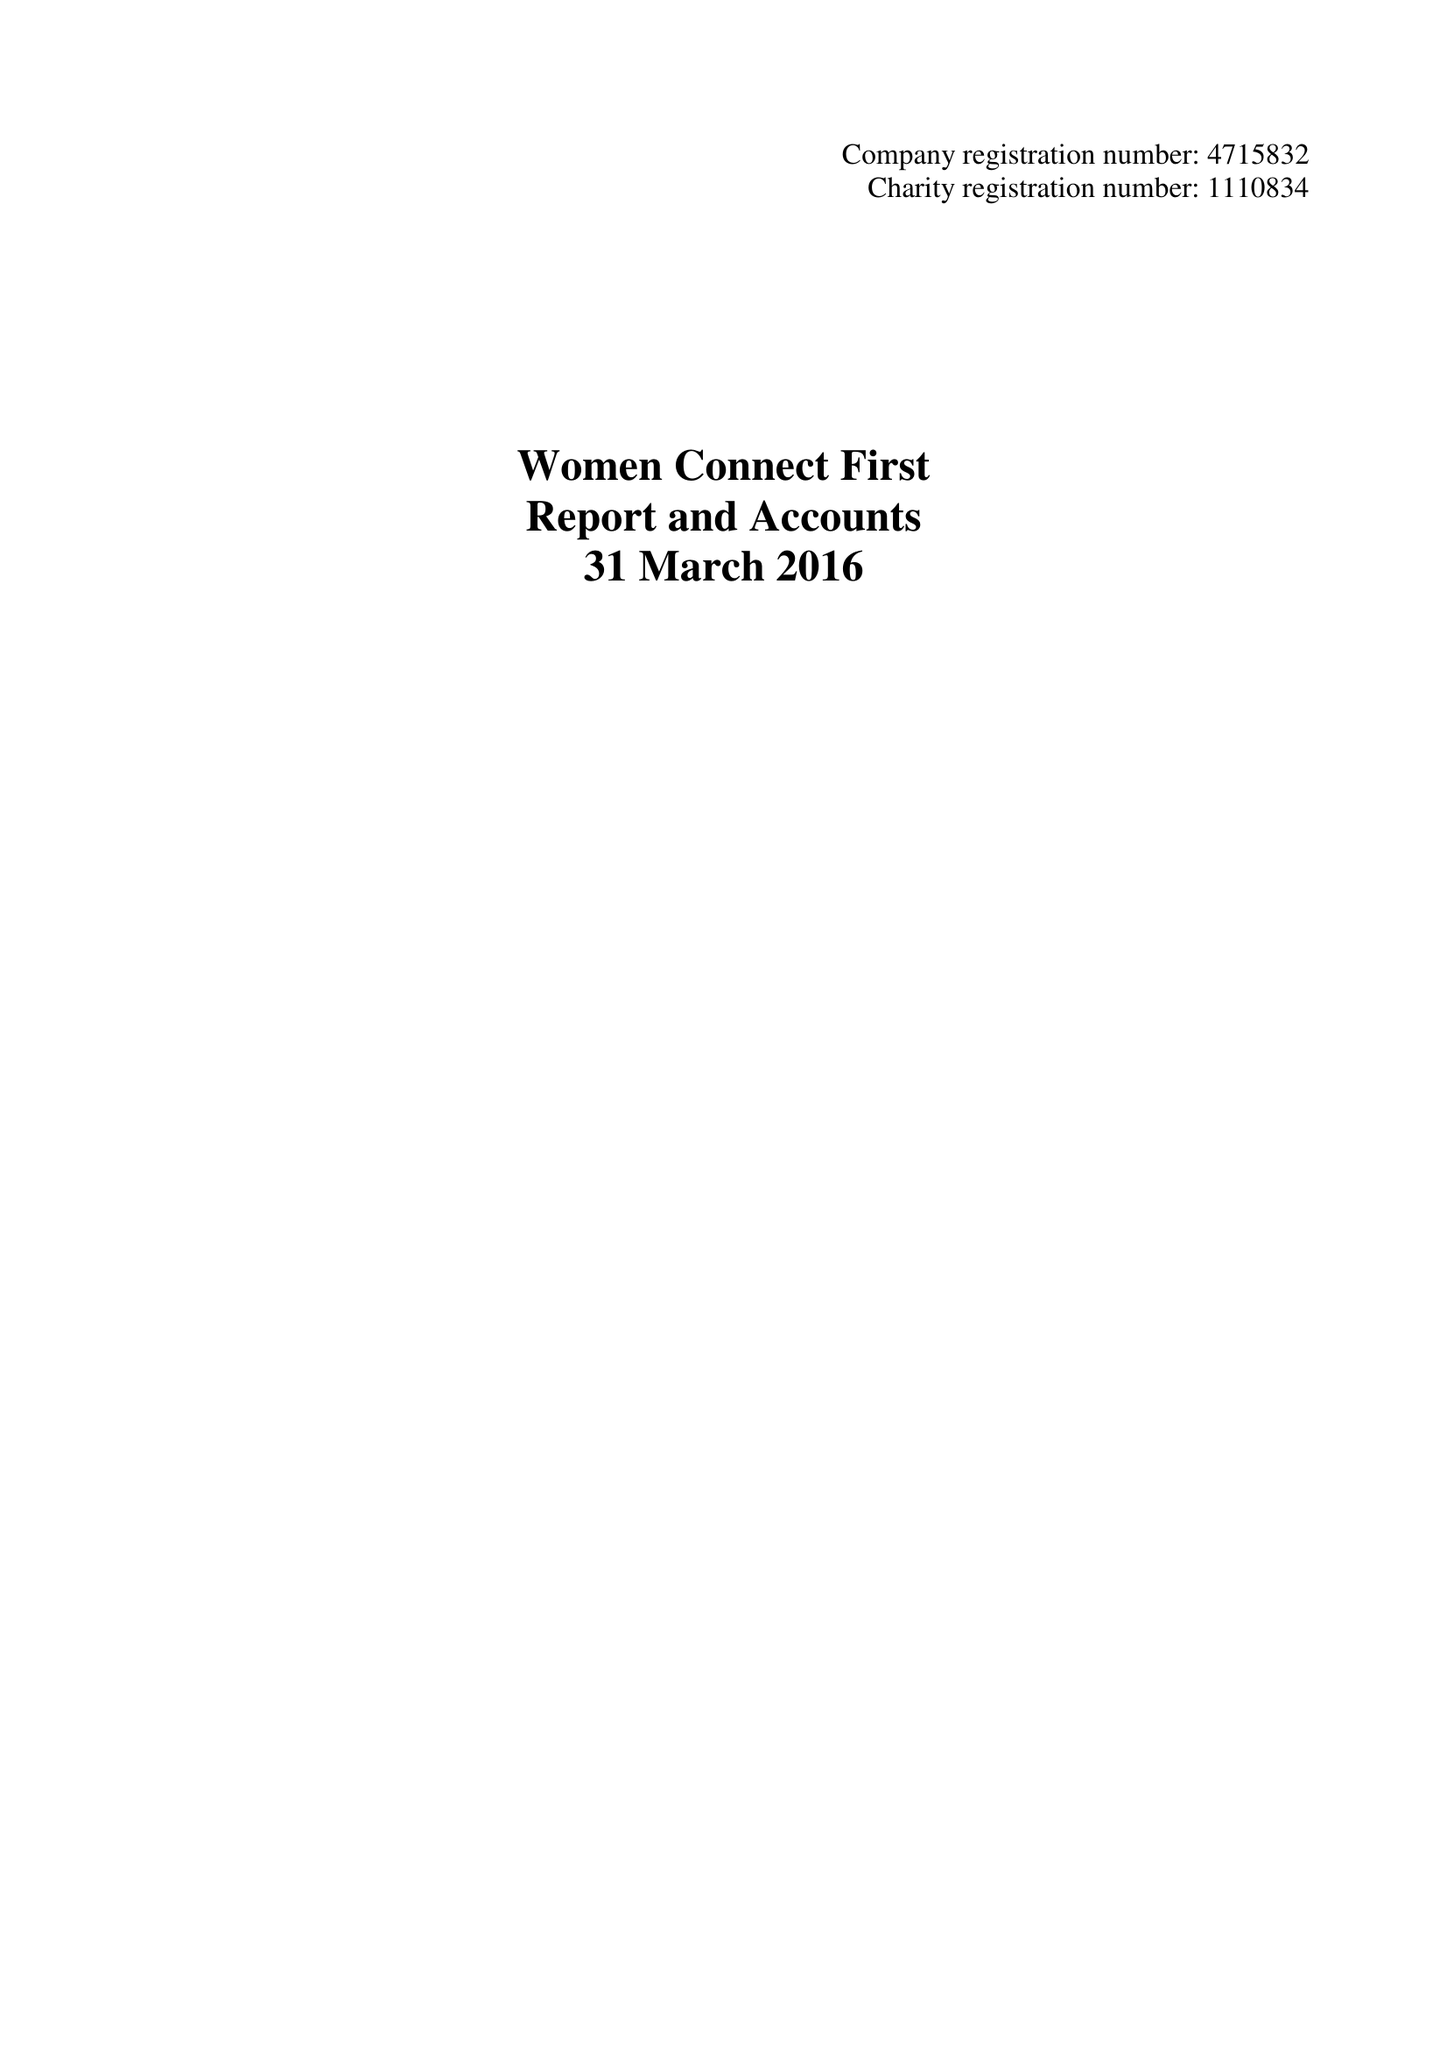What is the value for the address__post_town?
Answer the question using a single word or phrase. CARDIFF 